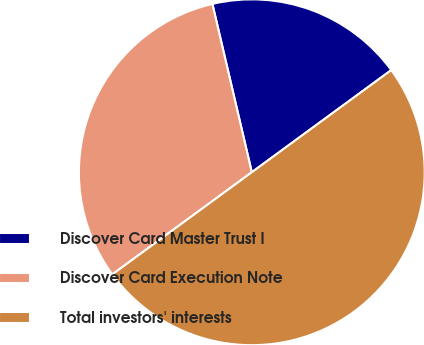<chart> <loc_0><loc_0><loc_500><loc_500><pie_chart><fcel>Discover Card Master Trust I<fcel>Discover Card Execution Note<fcel>Total investors' interests<nl><fcel>18.6%<fcel>31.4%<fcel>50.0%<nl></chart> 